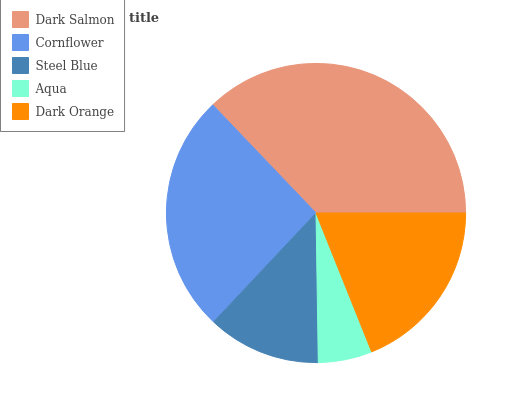Is Aqua the minimum?
Answer yes or no. Yes. Is Dark Salmon the maximum?
Answer yes or no. Yes. Is Cornflower the minimum?
Answer yes or no. No. Is Cornflower the maximum?
Answer yes or no. No. Is Dark Salmon greater than Cornflower?
Answer yes or no. Yes. Is Cornflower less than Dark Salmon?
Answer yes or no. Yes. Is Cornflower greater than Dark Salmon?
Answer yes or no. No. Is Dark Salmon less than Cornflower?
Answer yes or no. No. Is Dark Orange the high median?
Answer yes or no. Yes. Is Dark Orange the low median?
Answer yes or no. Yes. Is Cornflower the high median?
Answer yes or no. No. Is Dark Salmon the low median?
Answer yes or no. No. 